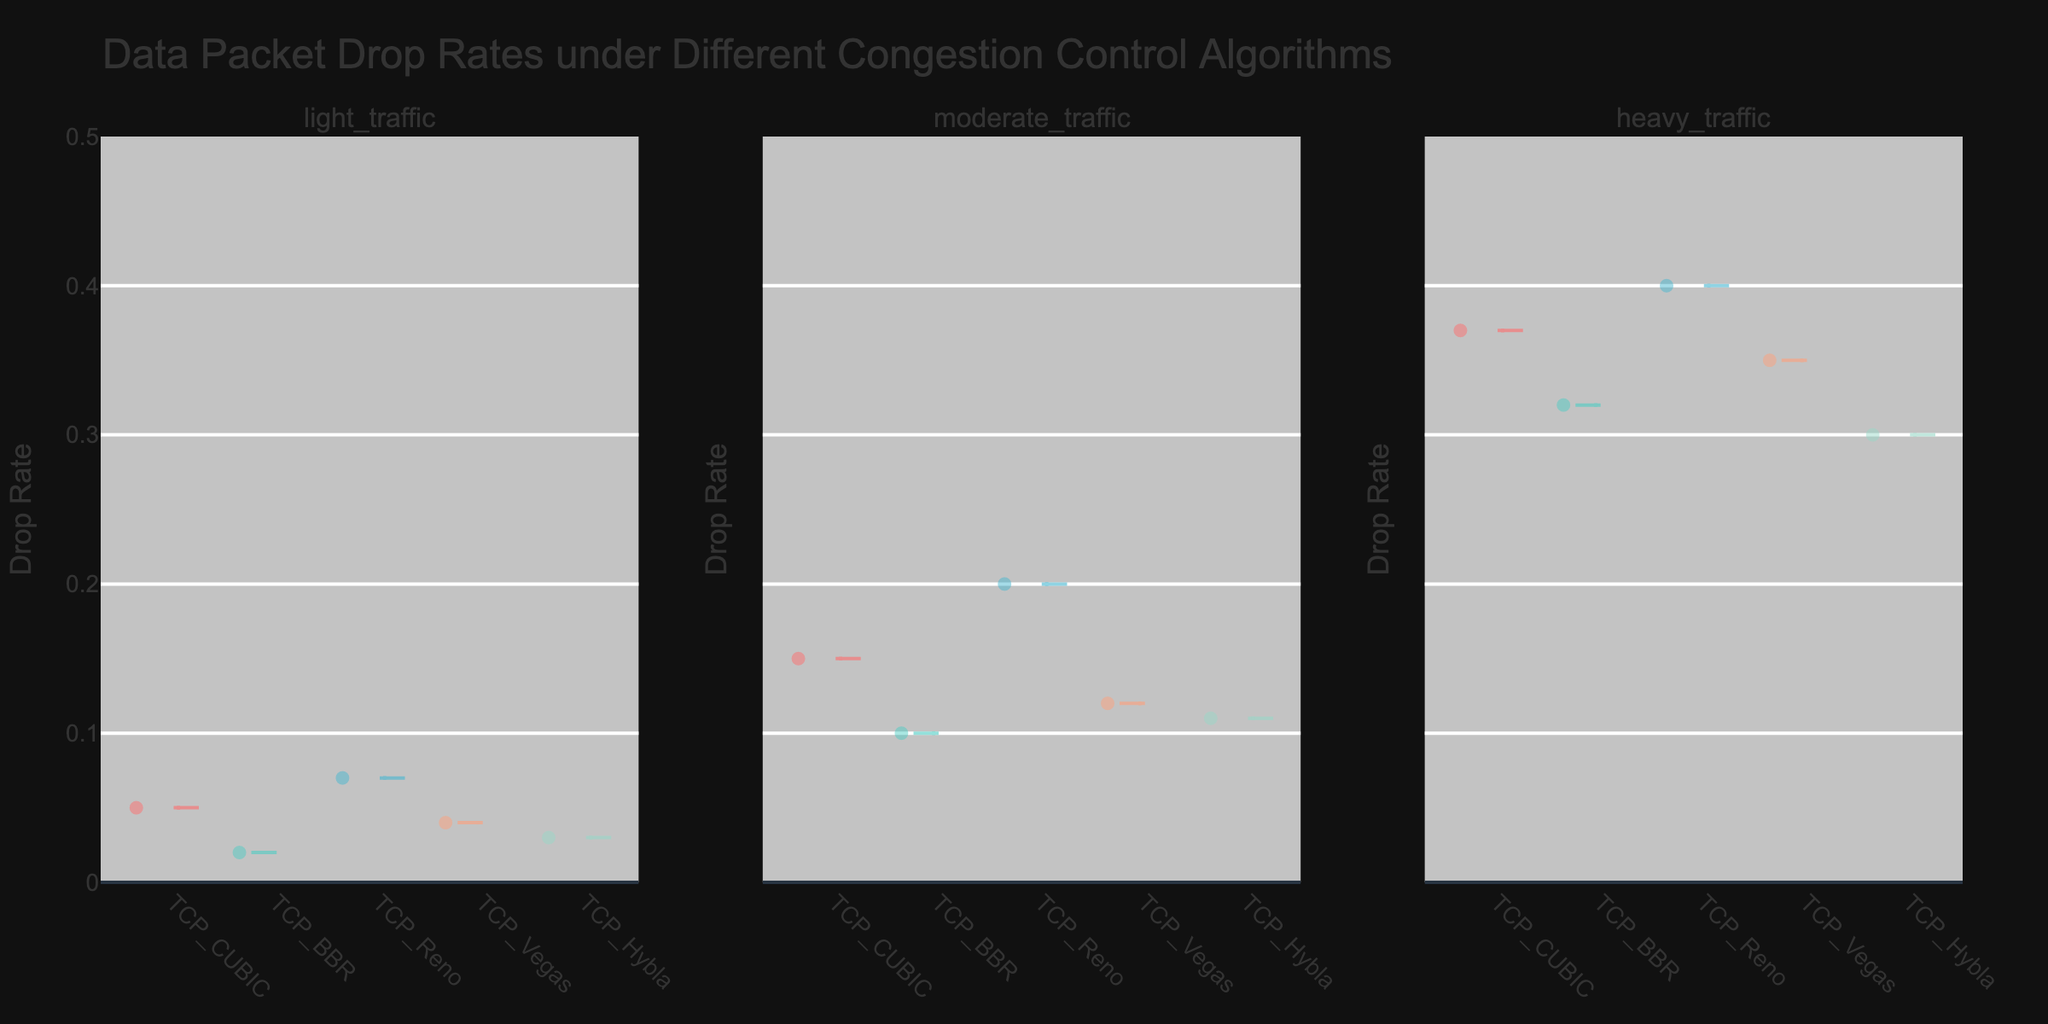What is the title of the figure? The title of the figure is typically found at the top-center of the plot area, and it describes the overall content of the plot. By looking at the plot, you can read the title directly.
Answer: Data Packet Drop Rates under Different Congestion Control Algorithms What does the y-axis represent? The y-axis is labeled to indicate what values it measures. In this case, the y-axis label should be visible on the left side of the plot.
Answer: Drop Rate What are the different network conditions shown in the plot? The subplot titles indicate different network conditions. These titles are located at the top of each subplot.
Answer: Light Traffic, Moderate Traffic, Heavy Traffic Which congestion control algorithm shows the lowest drop rate under heavy traffic? By looking at the subplots and focusing on the heavy traffic condition, you can observe the level of the lowest drop rate. Identify which algorithm corresponds to this lowest level.
Answer: TCP_Hybla How does the drop rate for TCP_Reno change across different network conditions? To answer this, you need to observe and compare the positions of the violin plots for TCP_Reno under light, moderate, and heavy traffic conditions.
Answer: Increases (0.07 in light traffic, 0.20 in moderate traffic, 0.40 in heavy traffic) Which algorithm has the most consistent drop rates across all network conditions? The most consistent algorithm would have relatively similar drop rates under light, moderate, and heavy traffic. Look at each algorithm's violin plots across the subplots and see which has the least variability.
Answer: TCP_BBR Between which two network conditions is the drop rate increase the largest for TCP_CUBIC? Compare the drop rates of TCP_CUBIC between light to moderate and moderate to heavy traffic conditions by observing the violin plots' spread.
Answer: Moderate Traffic to Heavy Traffic Which algorithm has the highest drop rate in moderate traffic? Identify the violin plot with the highest maximum value in the subsection labeled "Moderate Traffic".
Answer: TCP_Reno How does TCP_Vegas perform compared to TCP_CUBIC in light traffic? Look at the light traffic subplot and compare the positions and spread of the violin plots for TCP_Vegas and TCP_CUBIC.
Answer: TCP_Vegas has a lower drop rate Is there a general trend in drop rates as traffic conditions change from light to heavy? Examine the overall pattern of the violin plots across the subplots to determine if there is a common trend among the algorithms as traffic conditions change.
Answer: Drop rates generally increase 